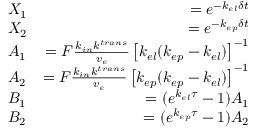<formula> <loc_0><loc_0><loc_500><loc_500>\begin{array} { r l r } & { X _ { 1 } } & { = e ^ { - k _ { e l } \delta t } } \\ & { X _ { 2 } } & { = e ^ { - k _ { e p } \delta t } } \\ & { A _ { 1 } } & { = F \frac { k _ { i n } k ^ { t r a n s } } { v _ { e } } \left [ k _ { e l } ( k _ { e p } - k _ { e l } ) \right ] ^ { - 1 } } \\ & { A _ { 2 } } & { = F \frac { k _ { i n } k ^ { t r a n s } } { v _ { e } } \left [ k _ { e p } ( k _ { e p } - k _ { e l } ) \right ] ^ { - 1 } } \\ & { B _ { 1 } } & { = ( e ^ { k _ { e l } \tau } - 1 ) A _ { 1 } } \\ & { B _ { 2 } } & { = ( e ^ { k _ { e p } \tau } - 1 ) A _ { 2 } } \end{array}</formula> 